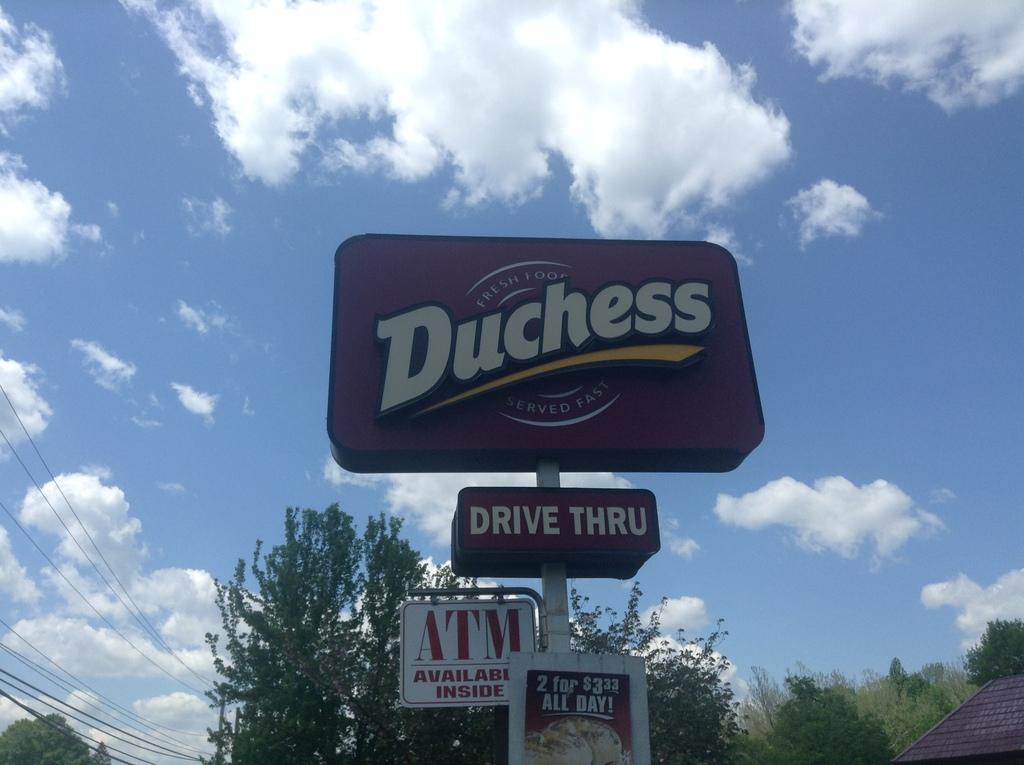<image>
Describe the image concisely. Sign that says Duchess drive thru and atm available inside 